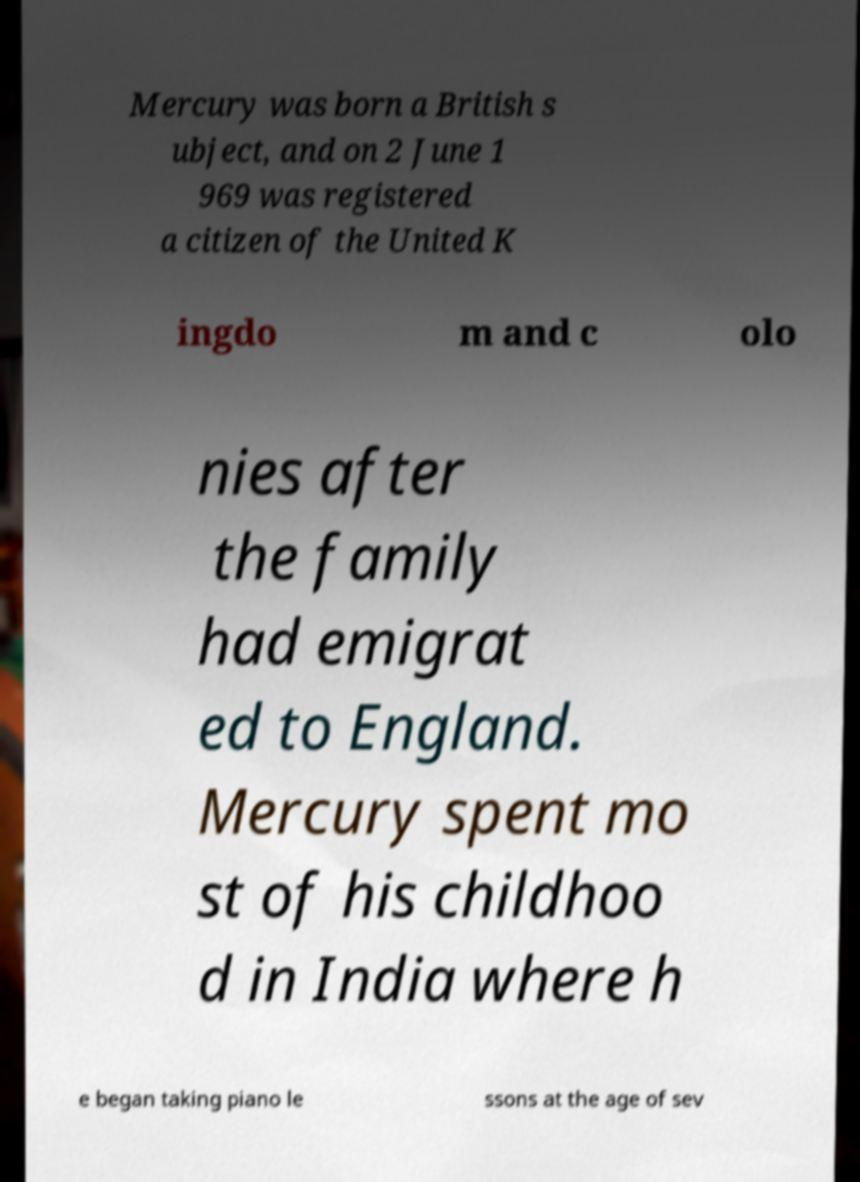Could you assist in decoding the text presented in this image and type it out clearly? Mercury was born a British s ubject, and on 2 June 1 969 was registered a citizen of the United K ingdo m and c olo nies after the family had emigrat ed to England. Mercury spent mo st of his childhoo d in India where h e began taking piano le ssons at the age of sev 